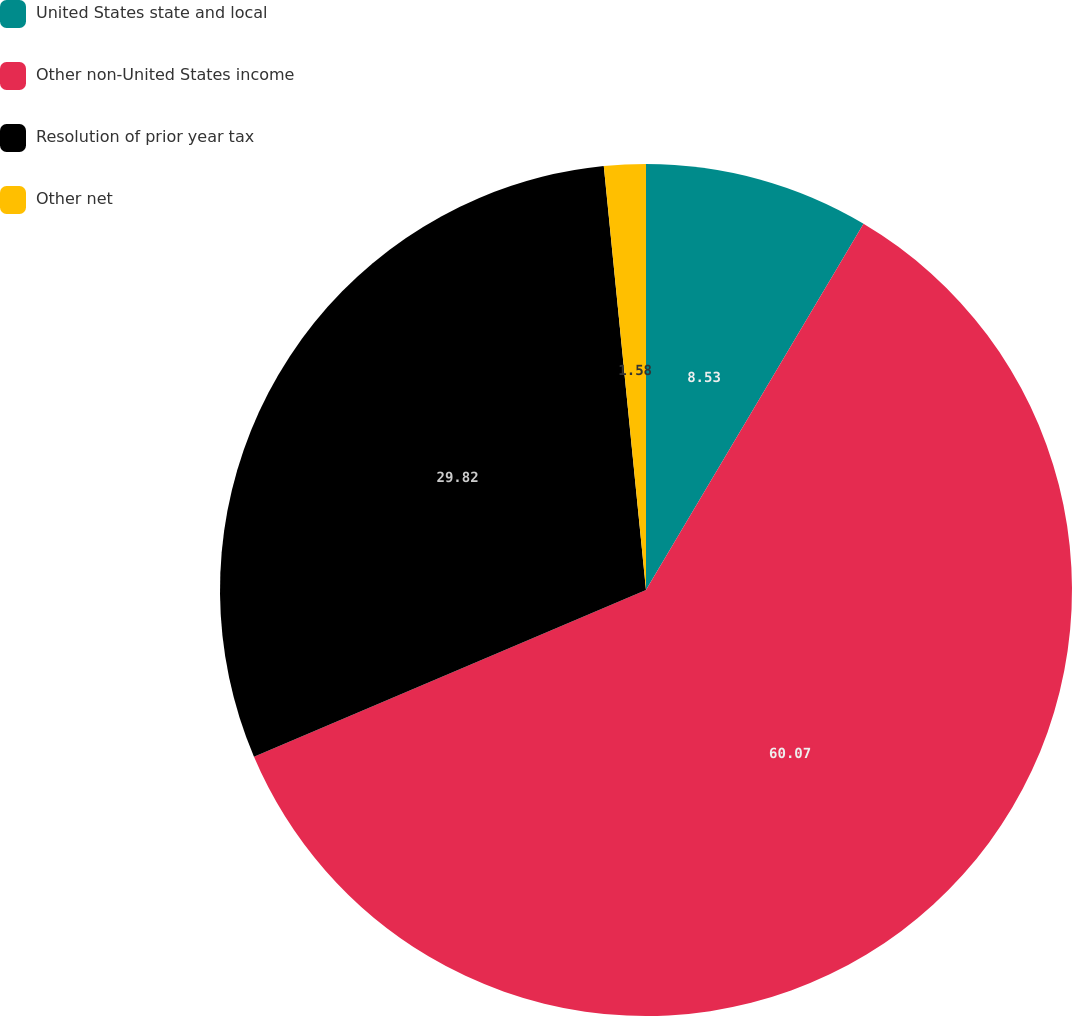<chart> <loc_0><loc_0><loc_500><loc_500><pie_chart><fcel>United States state and local<fcel>Other non-United States income<fcel>Resolution of prior year tax<fcel>Other net<nl><fcel>8.53%<fcel>60.07%<fcel>29.82%<fcel>1.58%<nl></chart> 